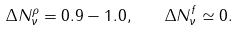<formula> <loc_0><loc_0><loc_500><loc_500>\Delta N _ { \nu } ^ { \rho } = 0 . 9 - 1 . 0 , \quad \Delta N _ { \nu } ^ { f } \simeq 0 .</formula> 